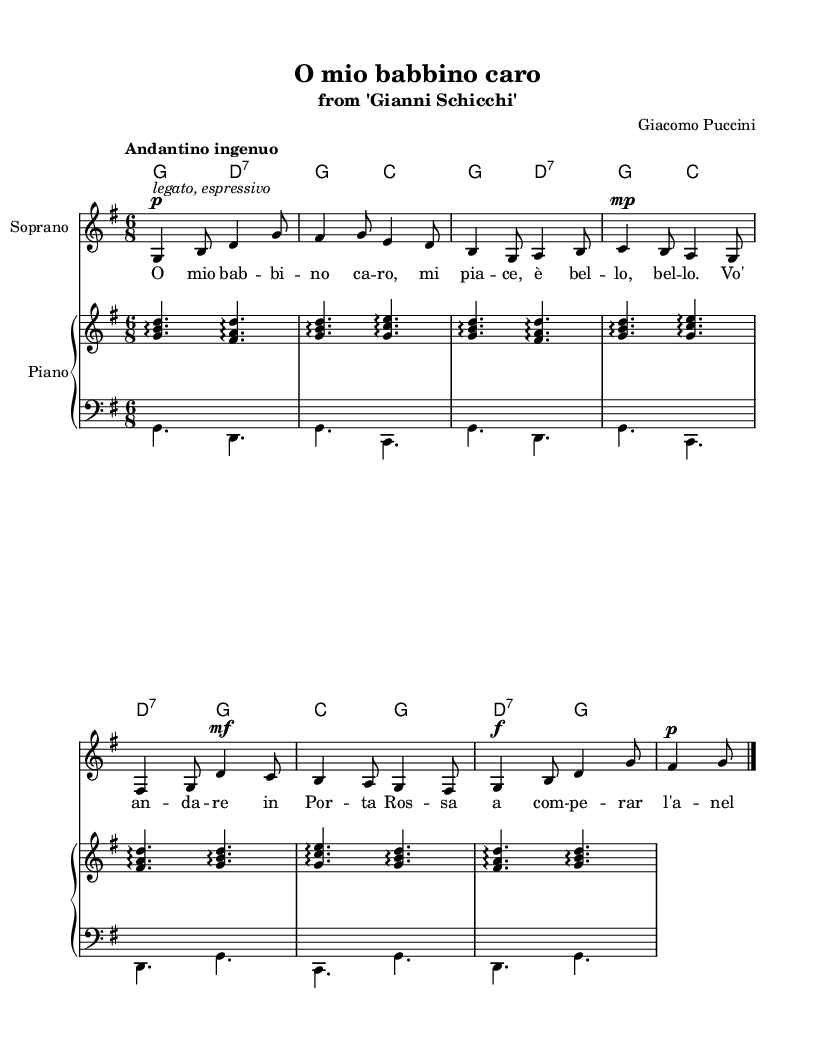What is the key signature of this music? The key signature displayed is G major, which has one sharp (F#). This can be identified by looking at the key signature at the beginning of the staff.
Answer: G major What is the time signature of this piece? The time signature shown is 6/8, indicated at the beginning of the score. This means there are six eighth notes per measure, which can be verified by counting the beats in the measure.
Answer: 6/8 What is the indicated tempo for this aria? The tempo marking in the score reads "Andantino ingenuo," which suggests a moderately slow and straightforward pace. This can be found at the start of the piece under the tempo indication.
Answer: Andantino ingenuo What is the first note of the melody? The first note of the melody in the score is G, which can be determined by locating the first note on the staff.
Answer: G How many measures are there in the piece? The score contains a total of eight measures. Counting the measures from the beginning to the end of the music provides this total.
Answer: Eight What vocal type is this aria written for? This aria is specifically written for a soprano voice, indicated by the label "Soprano" on the vocal staff.
Answer: Soprano What is the dynamic marking for the first phrase of the melody? The first phrase of the melody has a dynamic marking of piano, indicated with the symbol p. This notation is placed right before the first note of the melody.
Answer: Piano 